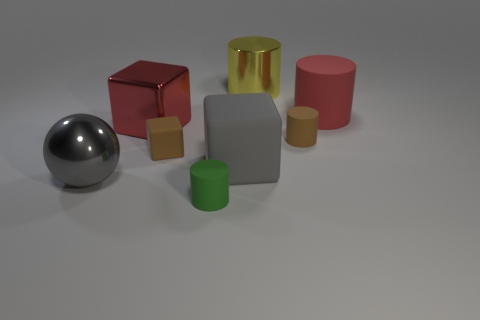Subtract all matte cylinders. How many cylinders are left? 1 Subtract all gray cubes. How many cubes are left? 2 Add 1 yellow shiny things. How many objects exist? 9 Subtract all balls. How many objects are left? 7 Subtract all large yellow cylinders. Subtract all tiny purple spheres. How many objects are left? 7 Add 3 tiny rubber blocks. How many tiny rubber blocks are left? 4 Add 8 gray matte objects. How many gray matte objects exist? 9 Subtract 0 red balls. How many objects are left? 8 Subtract 3 cylinders. How many cylinders are left? 1 Subtract all purple cylinders. Subtract all green blocks. How many cylinders are left? 4 